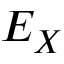Convert formula to latex. <formula><loc_0><loc_0><loc_500><loc_500>E _ { X }</formula> 